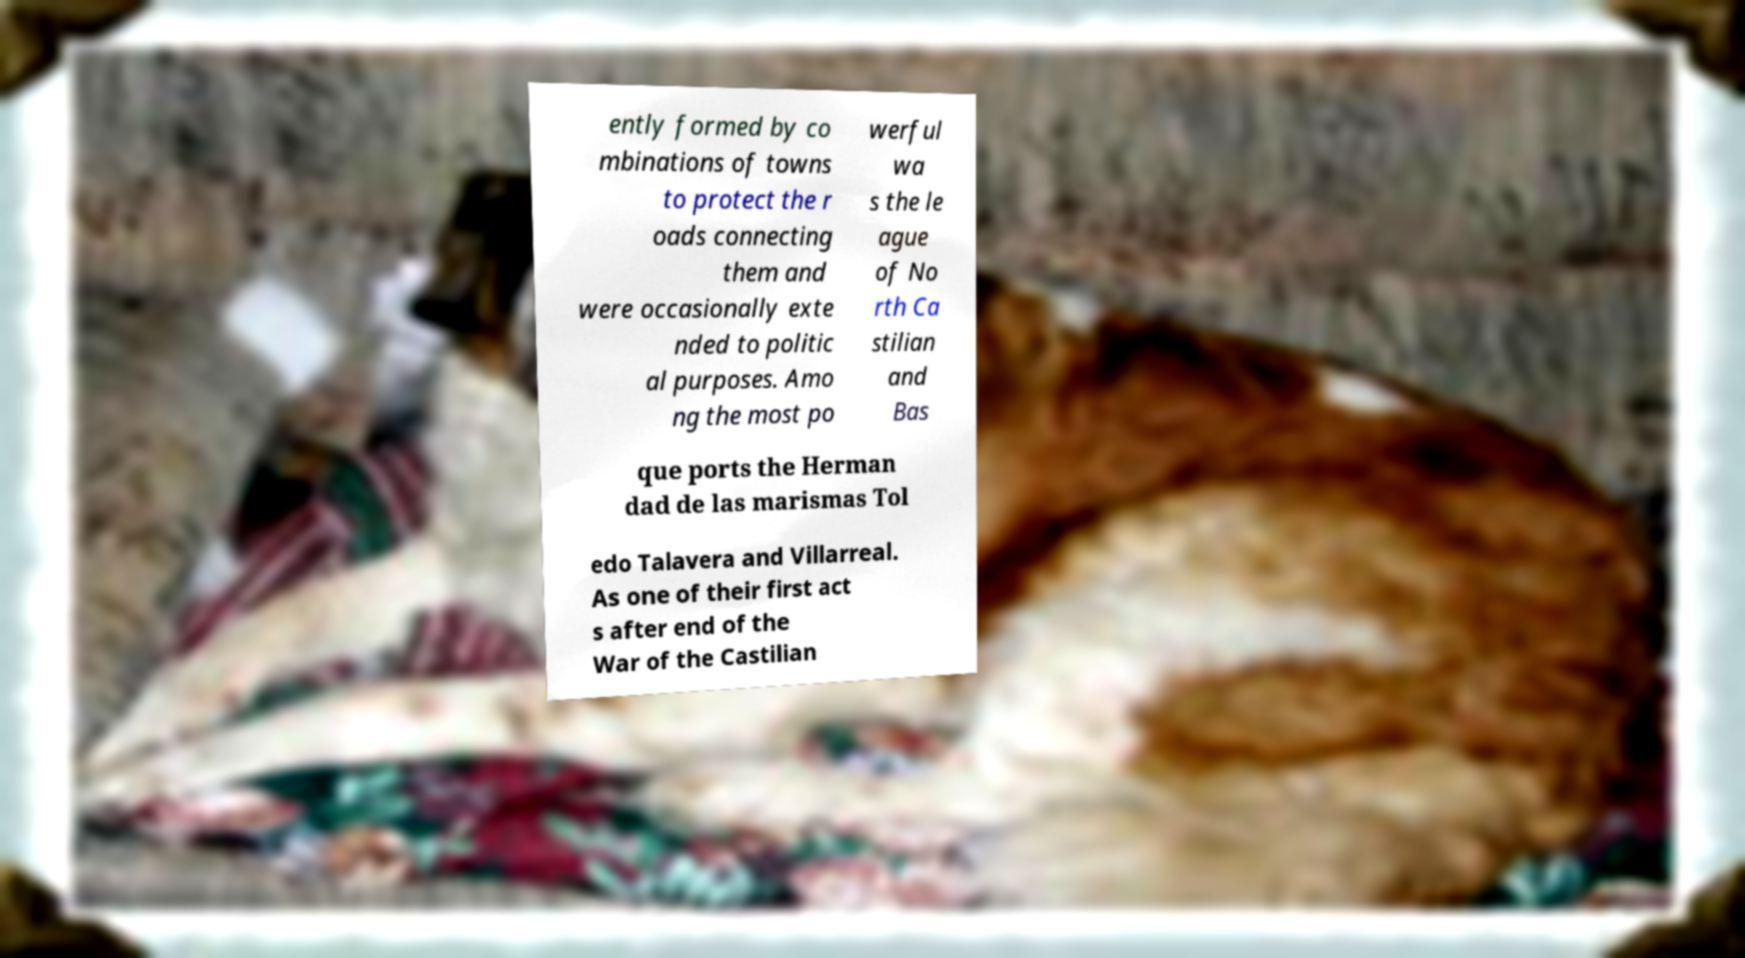I need the written content from this picture converted into text. Can you do that? ently formed by co mbinations of towns to protect the r oads connecting them and were occasionally exte nded to politic al purposes. Amo ng the most po werful wa s the le ague of No rth Ca stilian and Bas que ports the Herman dad de las marismas Tol edo Talavera and Villarreal. As one of their first act s after end of the War of the Castilian 